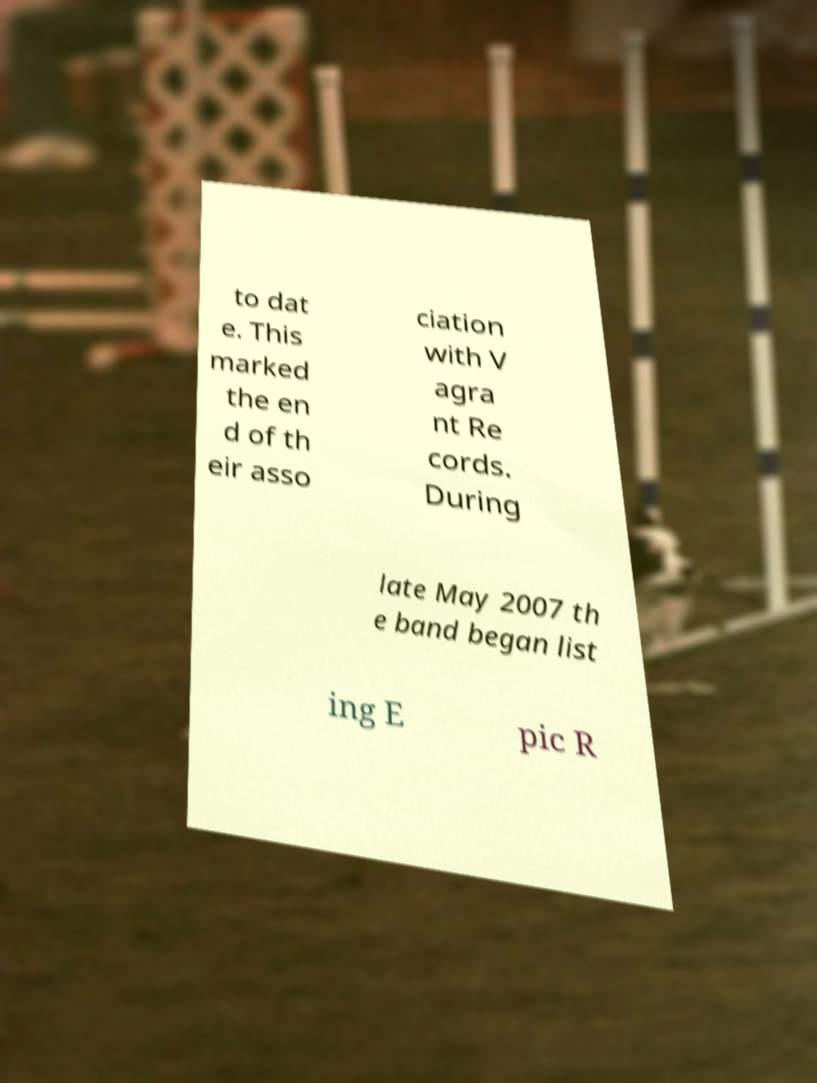For documentation purposes, I need the text within this image transcribed. Could you provide that? to dat e. This marked the en d of th eir asso ciation with V agra nt Re cords. During late May 2007 th e band began list ing E pic R 